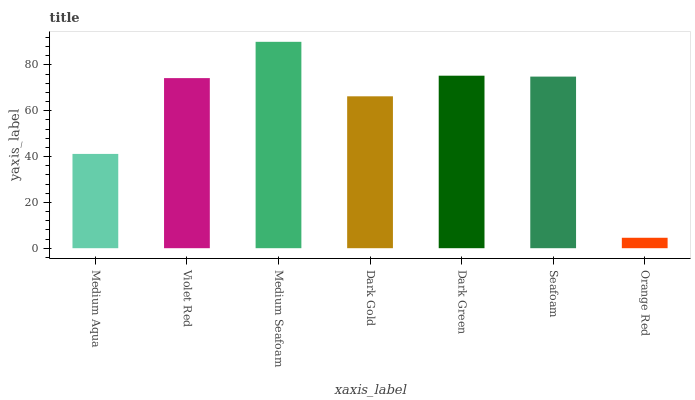Is Orange Red the minimum?
Answer yes or no. Yes. Is Medium Seafoam the maximum?
Answer yes or no. Yes. Is Violet Red the minimum?
Answer yes or no. No. Is Violet Red the maximum?
Answer yes or no. No. Is Violet Red greater than Medium Aqua?
Answer yes or no. Yes. Is Medium Aqua less than Violet Red?
Answer yes or no. Yes. Is Medium Aqua greater than Violet Red?
Answer yes or no. No. Is Violet Red less than Medium Aqua?
Answer yes or no. No. Is Violet Red the high median?
Answer yes or no. Yes. Is Violet Red the low median?
Answer yes or no. Yes. Is Medium Aqua the high median?
Answer yes or no. No. Is Medium Aqua the low median?
Answer yes or no. No. 